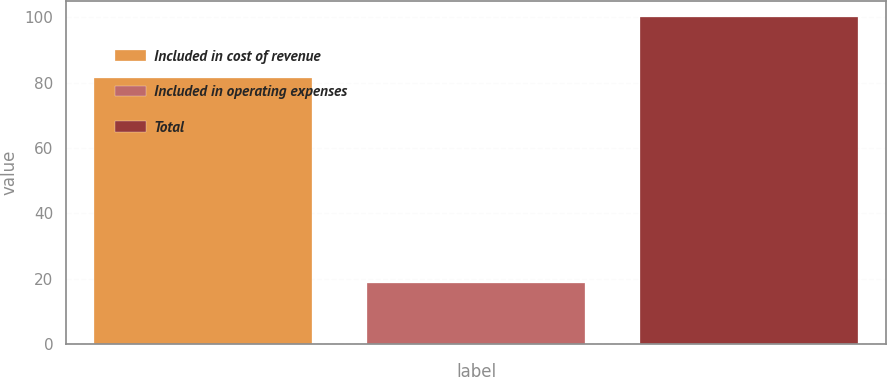Convert chart to OTSL. <chart><loc_0><loc_0><loc_500><loc_500><bar_chart><fcel>Included in cost of revenue<fcel>Included in operating expenses<fcel>Total<nl><fcel>81.3<fcel>18.6<fcel>99.9<nl></chart> 